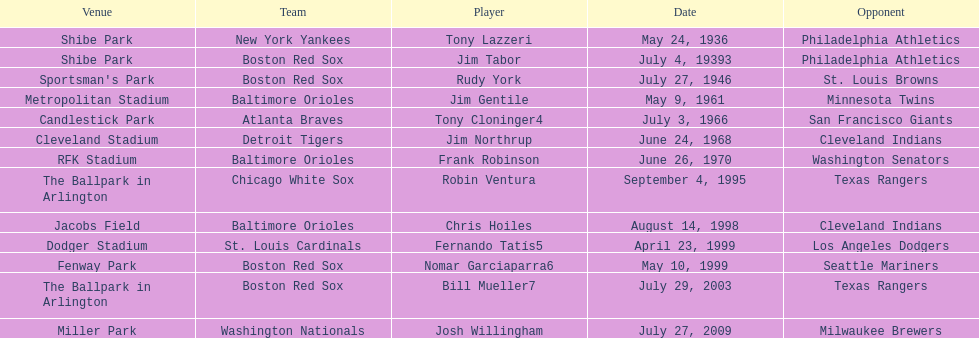On what date did the detroit tigers play the cleveland indians? June 24, 1968. 